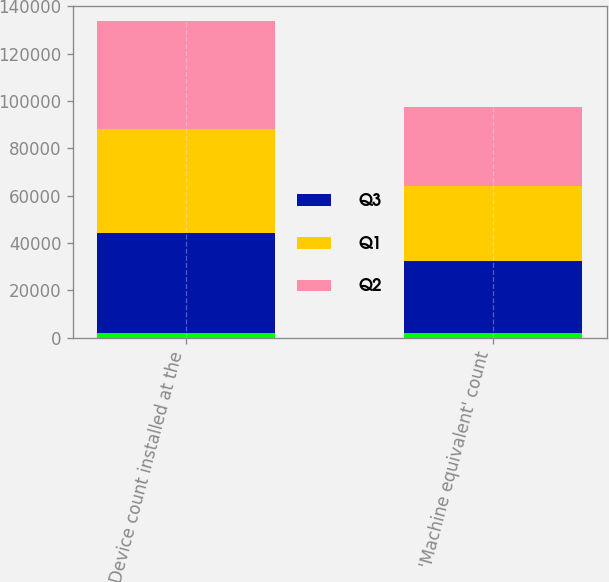Convert chart to OTSL. <chart><loc_0><loc_0><loc_500><loc_500><stacked_bar_chart><ecel><fcel>Device count installed at the<fcel>'Machine equivalent' count<nl><fcel>nan<fcel>2014<fcel>2014<nl><fcel>Q3<fcel>42153<fcel>30326<nl><fcel>Q1<fcel>43761<fcel>31713<nl><fcel>Q2<fcel>45596<fcel>33296<nl></chart> 